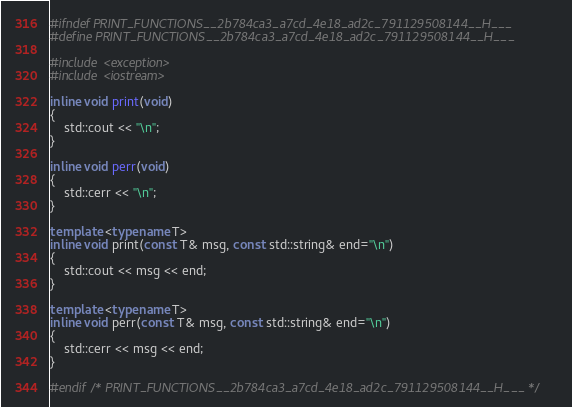<code> <loc_0><loc_0><loc_500><loc_500><_C++_>#ifndef PRINT_FUNCTIONS__2b784ca3_a7cd_4e18_ad2c_791129508144__H___
#define PRINT_FUNCTIONS__2b784ca3_a7cd_4e18_ad2c_791129508144__H___

#include <exception>
#include <iostream>

inline void print(void)
{ 
    std::cout << "\n"; 
}

inline void perr(void)
{
    std::cerr << "\n";
}

template <typename T> 
inline void print(const T& msg, const std::string& end="\n")
{
    std::cout << msg << end;
}

template <typename T>
inline void perr(const T& msg, const std::string& end="\n")
{
    std::cerr << msg << end;
}

#endif /* PRINT_FUNCTIONS__2b784ca3_a7cd_4e18_ad2c_791129508144__H___ */</code> 